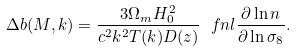<formula> <loc_0><loc_0><loc_500><loc_500>\Delta b ( M , k ) = \frac { 3 \Omega _ { m } H _ { 0 } ^ { 2 } } { c ^ { 2 } k ^ { 2 } T ( k ) D ( z ) } \ f n l \frac { \partial \ln n } { \partial \ln \sigma _ { 8 } } .</formula> 